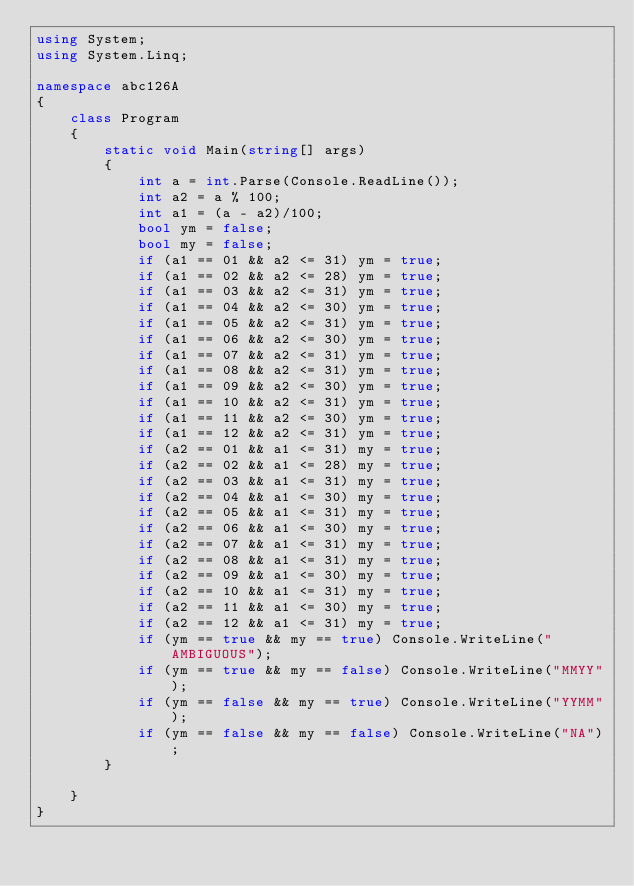Convert code to text. <code><loc_0><loc_0><loc_500><loc_500><_C#_>using System;
using System.Linq;

namespace abc126A
{
    class Program
    {
        static void Main(string[] args)
        {
            int a = int.Parse(Console.ReadLine());
            int a2 = a % 100;
            int a1 = (a - a2)/100;
            bool ym = false;
            bool my = false;
            if (a1 == 01 && a2 <= 31) ym = true;
            if (a1 == 02 && a2 <= 28) ym = true;
            if (a1 == 03 && a2 <= 31) ym = true;
            if (a1 == 04 && a2 <= 30) ym = true;
            if (a1 == 05 && a2 <= 31) ym = true;
            if (a1 == 06 && a2 <= 30) ym = true;
            if (a1 == 07 && a2 <= 31) ym = true;
            if (a1 == 08 && a2 <= 31) ym = true;
            if (a1 == 09 && a2 <= 30) ym = true;
            if (a1 == 10 && a2 <= 31) ym = true;
            if (a1 == 11 && a2 <= 30) ym = true;
            if (a1 == 12 && a2 <= 31) ym = true;
            if (a2 == 01 && a1 <= 31) my = true;
            if (a2 == 02 && a1 <= 28) my = true;
            if (a2 == 03 && a1 <= 31) my = true;
            if (a2 == 04 && a1 <= 30) my = true;
            if (a2 == 05 && a1 <= 31) my = true;
            if (a2 == 06 && a1 <= 30) my = true;
            if (a2 == 07 && a1 <= 31) my = true;
            if (a2 == 08 && a1 <= 31) my = true;
            if (a2 == 09 && a1 <= 30) my = true;
            if (a2 == 10 && a1 <= 31) my = true;
            if (a2 == 11 && a1 <= 30) my = true;
            if (a2 == 12 && a1 <= 31) my = true;
            if (ym == true && my == true) Console.WriteLine("AMBIGUOUS");
            if (ym == true && my == false) Console.WriteLine("MMYY");
            if (ym == false && my == true) Console.WriteLine("YYMM");
            if (ym == false && my == false) Console.WriteLine("NA");
        }

    }
}
</code> 